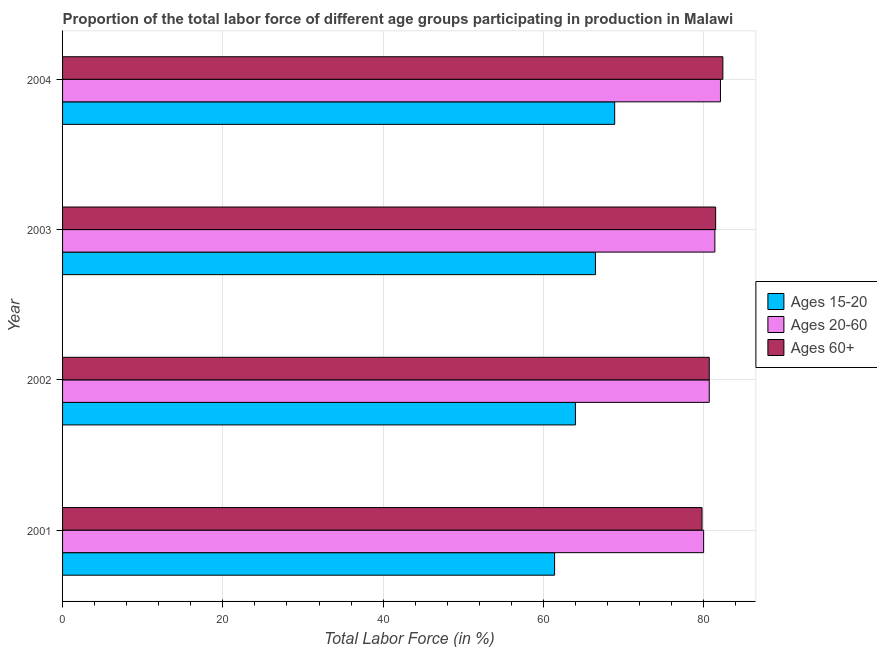Are the number of bars per tick equal to the number of legend labels?
Offer a very short reply. Yes. Are the number of bars on each tick of the Y-axis equal?
Provide a succinct answer. Yes. How many bars are there on the 4th tick from the bottom?
Give a very brief answer. 3. What is the percentage of labor force within the age group 20-60 in 2004?
Offer a very short reply. 82.1. Across all years, what is the maximum percentage of labor force within the age group 20-60?
Provide a short and direct response. 82.1. Across all years, what is the minimum percentage of labor force above age 60?
Offer a terse response. 79.8. What is the total percentage of labor force within the age group 20-60 in the graph?
Your answer should be compact. 324.2. What is the difference between the percentage of labor force above age 60 in 2002 and the percentage of labor force within the age group 20-60 in 2004?
Offer a terse response. -1.4. What is the average percentage of labor force above age 60 per year?
Offer a terse response. 81.1. In the year 2002, what is the difference between the percentage of labor force within the age group 20-60 and percentage of labor force within the age group 15-20?
Provide a short and direct response. 16.7. Is the percentage of labor force above age 60 in 2003 less than that in 2004?
Give a very brief answer. Yes. What is the difference between the highest and the second highest percentage of labor force within the age group 20-60?
Your response must be concise. 0.7. What is the difference between the highest and the lowest percentage of labor force above age 60?
Offer a very short reply. 2.6. What does the 1st bar from the top in 2003 represents?
Your answer should be very brief. Ages 60+. What does the 1st bar from the bottom in 2002 represents?
Offer a very short reply. Ages 15-20. Is it the case that in every year, the sum of the percentage of labor force within the age group 15-20 and percentage of labor force within the age group 20-60 is greater than the percentage of labor force above age 60?
Offer a terse response. Yes. How many bars are there?
Ensure brevity in your answer.  12. Where does the legend appear in the graph?
Keep it short and to the point. Center right. What is the title of the graph?
Give a very brief answer. Proportion of the total labor force of different age groups participating in production in Malawi. What is the Total Labor Force (in %) of Ages 15-20 in 2001?
Make the answer very short. 61.4. What is the Total Labor Force (in %) in Ages 60+ in 2001?
Provide a short and direct response. 79.8. What is the Total Labor Force (in %) in Ages 20-60 in 2002?
Give a very brief answer. 80.7. What is the Total Labor Force (in %) in Ages 60+ in 2002?
Offer a terse response. 80.7. What is the Total Labor Force (in %) in Ages 15-20 in 2003?
Keep it short and to the point. 66.5. What is the Total Labor Force (in %) in Ages 20-60 in 2003?
Provide a succinct answer. 81.4. What is the Total Labor Force (in %) in Ages 60+ in 2003?
Provide a succinct answer. 81.5. What is the Total Labor Force (in %) in Ages 15-20 in 2004?
Give a very brief answer. 68.9. What is the Total Labor Force (in %) of Ages 20-60 in 2004?
Offer a terse response. 82.1. What is the Total Labor Force (in %) of Ages 60+ in 2004?
Ensure brevity in your answer.  82.4. Across all years, what is the maximum Total Labor Force (in %) of Ages 15-20?
Give a very brief answer. 68.9. Across all years, what is the maximum Total Labor Force (in %) in Ages 20-60?
Your answer should be very brief. 82.1. Across all years, what is the maximum Total Labor Force (in %) of Ages 60+?
Provide a short and direct response. 82.4. Across all years, what is the minimum Total Labor Force (in %) in Ages 15-20?
Provide a short and direct response. 61.4. Across all years, what is the minimum Total Labor Force (in %) of Ages 60+?
Offer a terse response. 79.8. What is the total Total Labor Force (in %) in Ages 15-20 in the graph?
Ensure brevity in your answer.  260.8. What is the total Total Labor Force (in %) of Ages 20-60 in the graph?
Your answer should be very brief. 324.2. What is the total Total Labor Force (in %) in Ages 60+ in the graph?
Keep it short and to the point. 324.4. What is the difference between the Total Labor Force (in %) in Ages 60+ in 2001 and that in 2002?
Provide a short and direct response. -0.9. What is the difference between the Total Labor Force (in %) of Ages 15-20 in 2001 and that in 2003?
Keep it short and to the point. -5.1. What is the difference between the Total Labor Force (in %) in Ages 15-20 in 2001 and that in 2004?
Provide a succinct answer. -7.5. What is the difference between the Total Labor Force (in %) in Ages 20-60 in 2003 and that in 2004?
Ensure brevity in your answer.  -0.7. What is the difference between the Total Labor Force (in %) in Ages 60+ in 2003 and that in 2004?
Offer a terse response. -0.9. What is the difference between the Total Labor Force (in %) of Ages 15-20 in 2001 and the Total Labor Force (in %) of Ages 20-60 in 2002?
Your response must be concise. -19.3. What is the difference between the Total Labor Force (in %) in Ages 15-20 in 2001 and the Total Labor Force (in %) in Ages 60+ in 2002?
Provide a short and direct response. -19.3. What is the difference between the Total Labor Force (in %) of Ages 15-20 in 2001 and the Total Labor Force (in %) of Ages 60+ in 2003?
Offer a very short reply. -20.1. What is the difference between the Total Labor Force (in %) in Ages 15-20 in 2001 and the Total Labor Force (in %) in Ages 20-60 in 2004?
Your answer should be compact. -20.7. What is the difference between the Total Labor Force (in %) of Ages 15-20 in 2002 and the Total Labor Force (in %) of Ages 20-60 in 2003?
Give a very brief answer. -17.4. What is the difference between the Total Labor Force (in %) in Ages 15-20 in 2002 and the Total Labor Force (in %) in Ages 60+ in 2003?
Provide a succinct answer. -17.5. What is the difference between the Total Labor Force (in %) of Ages 20-60 in 2002 and the Total Labor Force (in %) of Ages 60+ in 2003?
Make the answer very short. -0.8. What is the difference between the Total Labor Force (in %) in Ages 15-20 in 2002 and the Total Labor Force (in %) in Ages 20-60 in 2004?
Offer a very short reply. -18.1. What is the difference between the Total Labor Force (in %) in Ages 15-20 in 2002 and the Total Labor Force (in %) in Ages 60+ in 2004?
Give a very brief answer. -18.4. What is the difference between the Total Labor Force (in %) in Ages 20-60 in 2002 and the Total Labor Force (in %) in Ages 60+ in 2004?
Provide a succinct answer. -1.7. What is the difference between the Total Labor Force (in %) in Ages 15-20 in 2003 and the Total Labor Force (in %) in Ages 20-60 in 2004?
Your answer should be very brief. -15.6. What is the difference between the Total Labor Force (in %) of Ages 15-20 in 2003 and the Total Labor Force (in %) of Ages 60+ in 2004?
Offer a very short reply. -15.9. What is the average Total Labor Force (in %) of Ages 15-20 per year?
Provide a succinct answer. 65.2. What is the average Total Labor Force (in %) in Ages 20-60 per year?
Make the answer very short. 81.05. What is the average Total Labor Force (in %) in Ages 60+ per year?
Give a very brief answer. 81.1. In the year 2001, what is the difference between the Total Labor Force (in %) in Ages 15-20 and Total Labor Force (in %) in Ages 20-60?
Provide a short and direct response. -18.6. In the year 2001, what is the difference between the Total Labor Force (in %) of Ages 15-20 and Total Labor Force (in %) of Ages 60+?
Provide a short and direct response. -18.4. In the year 2002, what is the difference between the Total Labor Force (in %) of Ages 15-20 and Total Labor Force (in %) of Ages 20-60?
Provide a short and direct response. -16.7. In the year 2002, what is the difference between the Total Labor Force (in %) in Ages 15-20 and Total Labor Force (in %) in Ages 60+?
Your response must be concise. -16.7. In the year 2002, what is the difference between the Total Labor Force (in %) in Ages 20-60 and Total Labor Force (in %) in Ages 60+?
Make the answer very short. 0. In the year 2003, what is the difference between the Total Labor Force (in %) of Ages 15-20 and Total Labor Force (in %) of Ages 20-60?
Keep it short and to the point. -14.9. In the year 2003, what is the difference between the Total Labor Force (in %) of Ages 15-20 and Total Labor Force (in %) of Ages 60+?
Your answer should be compact. -15. In the year 2004, what is the difference between the Total Labor Force (in %) in Ages 15-20 and Total Labor Force (in %) in Ages 20-60?
Ensure brevity in your answer.  -13.2. What is the ratio of the Total Labor Force (in %) of Ages 15-20 in 2001 to that in 2002?
Your answer should be very brief. 0.96. What is the ratio of the Total Labor Force (in %) in Ages 60+ in 2001 to that in 2002?
Provide a short and direct response. 0.99. What is the ratio of the Total Labor Force (in %) of Ages 15-20 in 2001 to that in 2003?
Keep it short and to the point. 0.92. What is the ratio of the Total Labor Force (in %) of Ages 20-60 in 2001 to that in 2003?
Your answer should be compact. 0.98. What is the ratio of the Total Labor Force (in %) of Ages 60+ in 2001 to that in 2003?
Keep it short and to the point. 0.98. What is the ratio of the Total Labor Force (in %) in Ages 15-20 in 2001 to that in 2004?
Your answer should be compact. 0.89. What is the ratio of the Total Labor Force (in %) of Ages 20-60 in 2001 to that in 2004?
Provide a succinct answer. 0.97. What is the ratio of the Total Labor Force (in %) in Ages 60+ in 2001 to that in 2004?
Make the answer very short. 0.97. What is the ratio of the Total Labor Force (in %) of Ages 15-20 in 2002 to that in 2003?
Your response must be concise. 0.96. What is the ratio of the Total Labor Force (in %) in Ages 20-60 in 2002 to that in 2003?
Offer a very short reply. 0.99. What is the ratio of the Total Labor Force (in %) in Ages 60+ in 2002 to that in 2003?
Provide a succinct answer. 0.99. What is the ratio of the Total Labor Force (in %) of Ages 15-20 in 2002 to that in 2004?
Your answer should be compact. 0.93. What is the ratio of the Total Labor Force (in %) of Ages 20-60 in 2002 to that in 2004?
Provide a short and direct response. 0.98. What is the ratio of the Total Labor Force (in %) in Ages 60+ in 2002 to that in 2004?
Your answer should be compact. 0.98. What is the ratio of the Total Labor Force (in %) of Ages 15-20 in 2003 to that in 2004?
Your answer should be compact. 0.97. What is the ratio of the Total Labor Force (in %) of Ages 20-60 in 2003 to that in 2004?
Offer a very short reply. 0.99. What is the ratio of the Total Labor Force (in %) in Ages 60+ in 2003 to that in 2004?
Keep it short and to the point. 0.99. What is the difference between the highest and the lowest Total Labor Force (in %) in Ages 15-20?
Provide a succinct answer. 7.5. What is the difference between the highest and the lowest Total Labor Force (in %) of Ages 60+?
Make the answer very short. 2.6. 